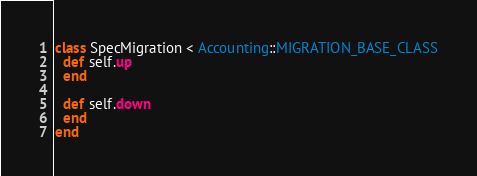Convert code to text. <code><loc_0><loc_0><loc_500><loc_500><_Ruby_>class SpecMigration < Accounting::MIGRATION_BASE_CLASS
  def self.up
  end

  def self.down
  end
end
</code> 